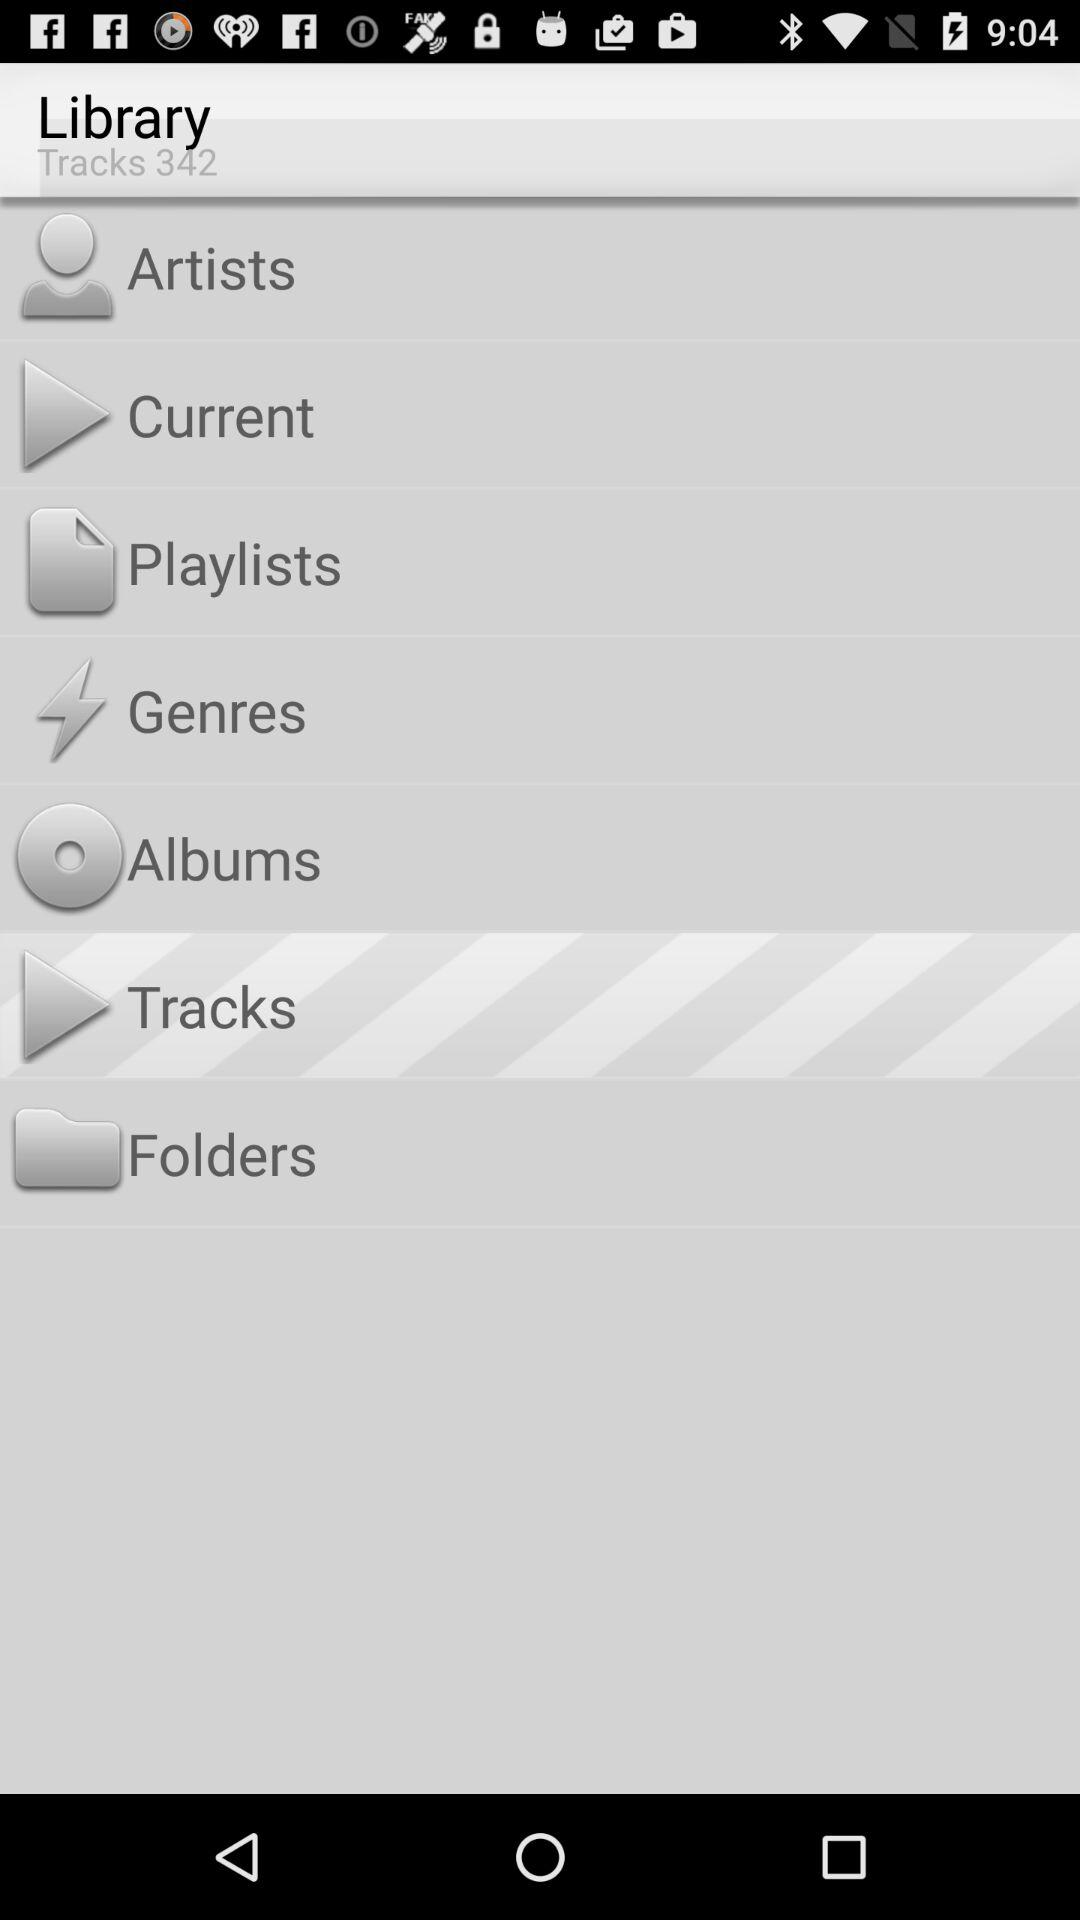Which option is selected? The selected option is "Tracks". 